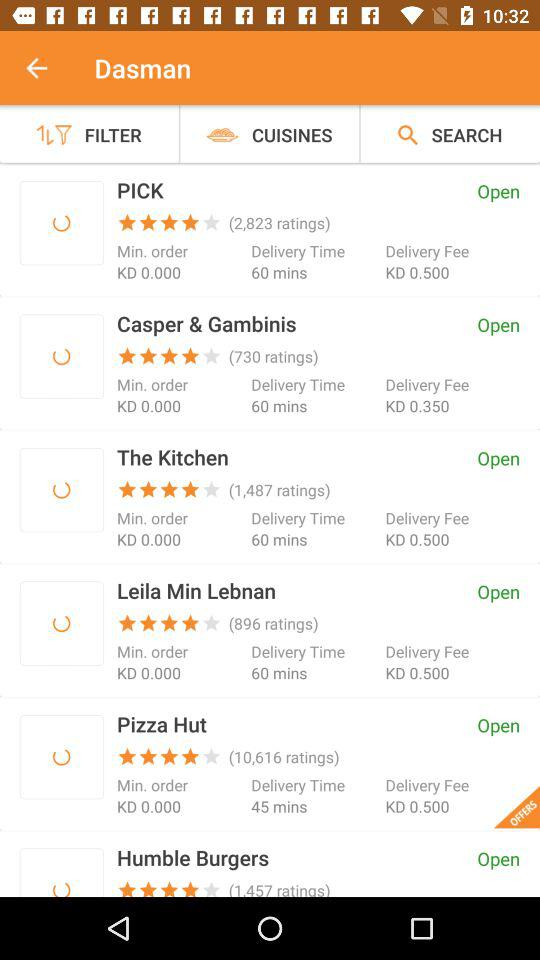What is the rating for "Pizza Hut"? The rating for "Pizza Hut" is 4 stars. 